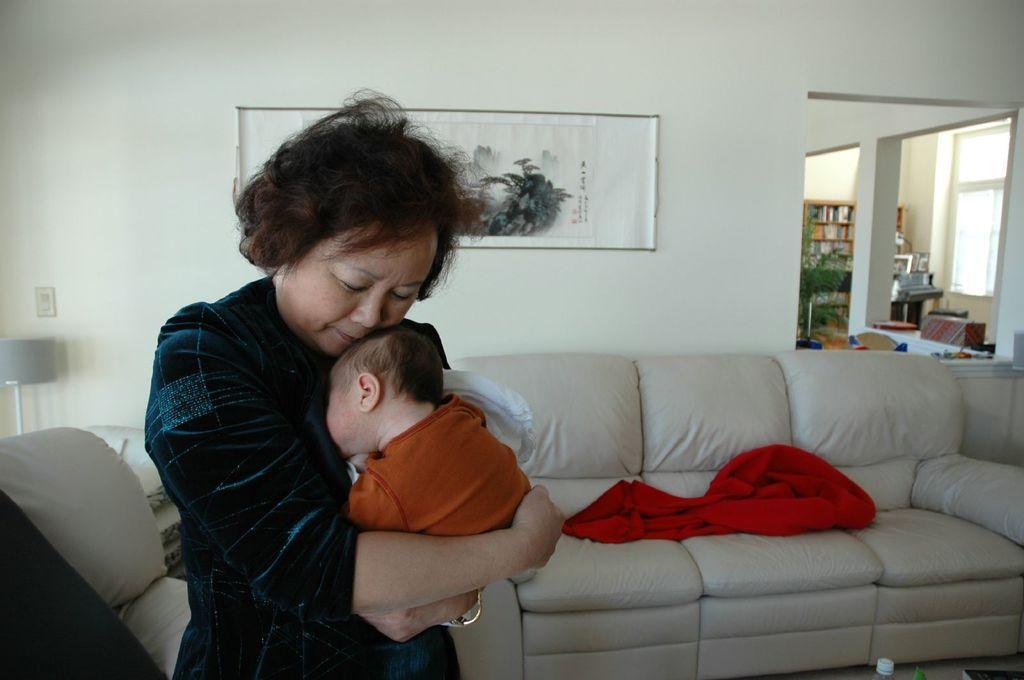Could you give a brief overview of what you see in this image? In this picture there is a woman, holding a baby in her hands. In the background there is a sofa on which a red color blanket was placed. There is a photo frame attached to the wall. In the background there is a pillar and a cupboard here. 